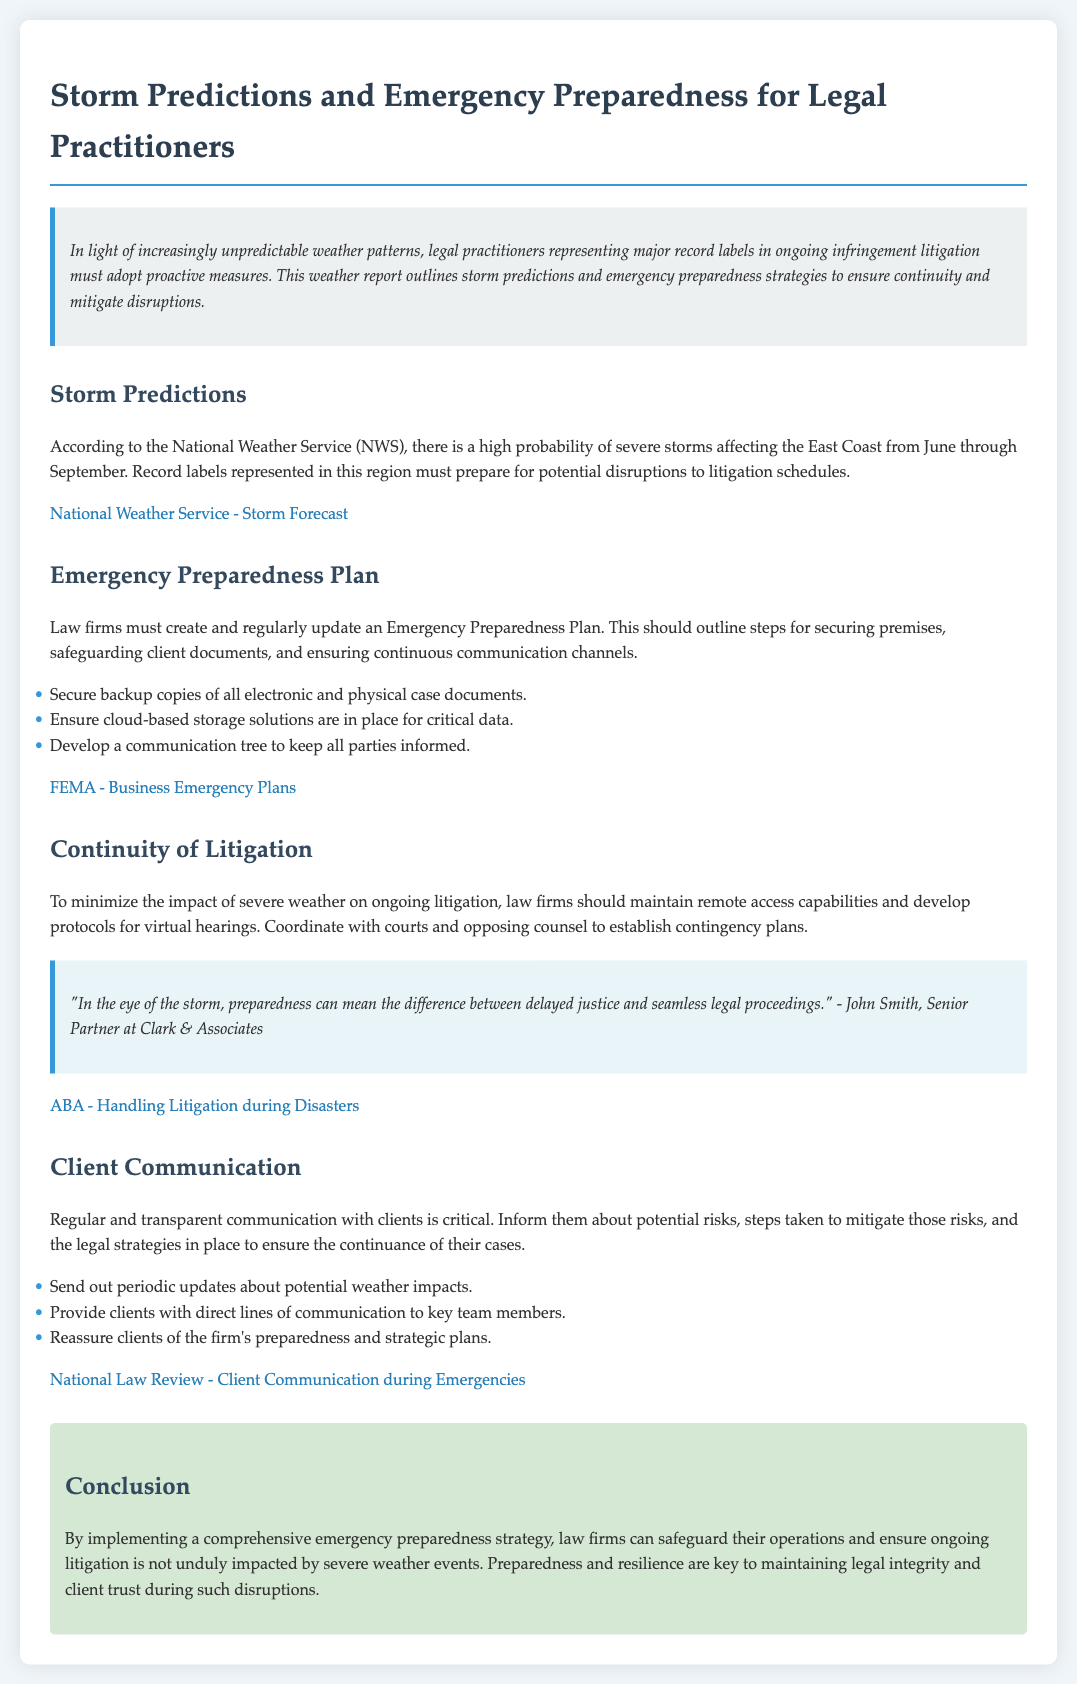What is the title of the document? The title is explicitly mentioned at the top of the document.
Answer: Storm Predictions and Emergency Preparedness for Legal Practitioners What is the main focus of the introduction section? The introduction discusses the need for legal practitioners to adopt proactive measures due to unpredictable weather patterns.
Answer: Proactive measures What time frame is mentioned for the high probability of severe storms? The document specifies a specific time period for severe storms affecting the East Coast in the NWS section.
Answer: June through September What should law firms secure according to the Emergency Preparedness Plan? The Emergency Preparedness Plan outlines specific measures for handling client documents.
Answer: Backup copies of all electronic and physical case documents What is a key element of maintaining litigation continuity mentioned in the document? The text specifies a particular capability that law firms should maintain to ensure continuity during severe weather.
Answer: Remote access capabilities What attitude should law firms have towards client communication during emergencies? The document characterizes the manner in which law firms should treat communication with clients during potential disruptions.
Answer: Regular and transparent communication Who is quoted in the document about preparedness during storms? The quote provides the name of a professional giving insight on storm preparedness impacts on legal proceedings.
Answer: John Smith What webpage is linked for business emergency plans? The document includes a URL related to emergency preparedness resources for businesses.
Answer: https://www.ready.gov/business What does the conclusion emphasize regarding law firms and severe weather? The conclusion summarizes the overall importance that law firms should retain in the face of severe weather events.
Answer: Preparedness and resilience 